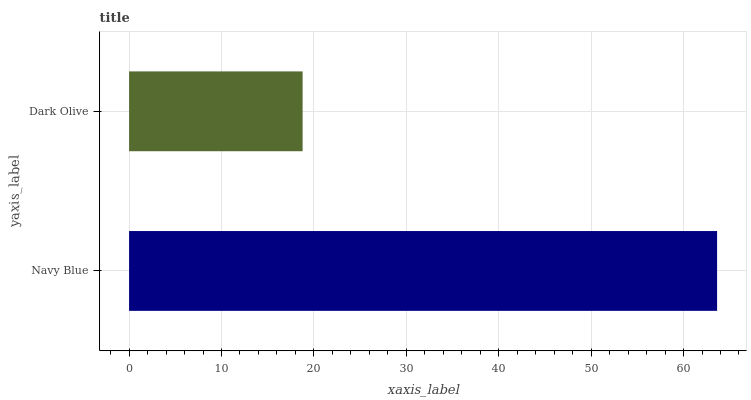Is Dark Olive the minimum?
Answer yes or no. Yes. Is Navy Blue the maximum?
Answer yes or no. Yes. Is Dark Olive the maximum?
Answer yes or no. No. Is Navy Blue greater than Dark Olive?
Answer yes or no. Yes. Is Dark Olive less than Navy Blue?
Answer yes or no. Yes. Is Dark Olive greater than Navy Blue?
Answer yes or no. No. Is Navy Blue less than Dark Olive?
Answer yes or no. No. Is Navy Blue the high median?
Answer yes or no. Yes. Is Dark Olive the low median?
Answer yes or no. Yes. Is Dark Olive the high median?
Answer yes or no. No. Is Navy Blue the low median?
Answer yes or no. No. 